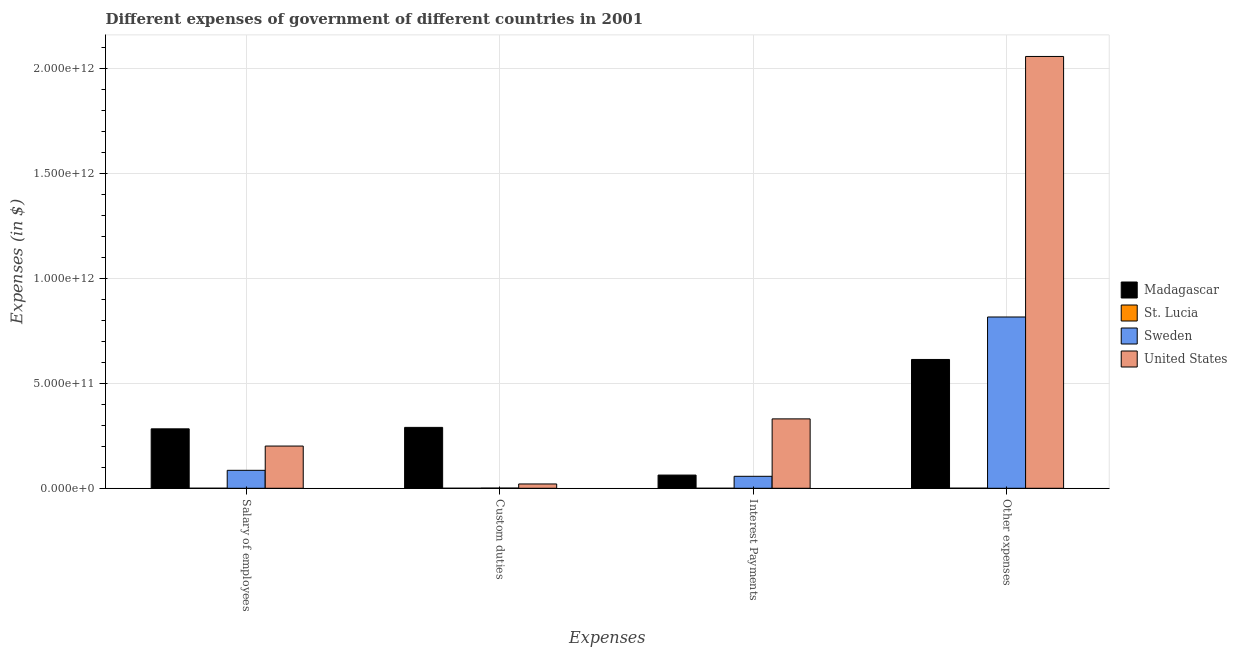How many groups of bars are there?
Give a very brief answer. 4. Are the number of bars per tick equal to the number of legend labels?
Provide a succinct answer. Yes. Are the number of bars on each tick of the X-axis equal?
Provide a short and direct response. Yes. What is the label of the 3rd group of bars from the left?
Your answer should be compact. Interest Payments. What is the amount spent on interest payments in St. Lucia?
Offer a very short reply. 4.08e+07. Across all countries, what is the maximum amount spent on other expenses?
Your answer should be very brief. 2.06e+12. Across all countries, what is the minimum amount spent on other expenses?
Provide a succinct answer. 4.01e+08. In which country was the amount spent on other expenses maximum?
Your answer should be compact. United States. In which country was the amount spent on salary of employees minimum?
Offer a terse response. St. Lucia. What is the total amount spent on salary of employees in the graph?
Offer a very short reply. 5.71e+11. What is the difference between the amount spent on other expenses in Madagascar and that in United States?
Provide a succinct answer. -1.45e+12. What is the difference between the amount spent on custom duties in Madagascar and the amount spent on other expenses in Sweden?
Offer a terse response. -5.27e+11. What is the average amount spent on custom duties per country?
Make the answer very short. 7.80e+1. What is the difference between the amount spent on custom duties and amount spent on other expenses in St. Lucia?
Provide a succinct answer. -3.18e+08. What is the ratio of the amount spent on custom duties in Madagascar to that in St. Lucia?
Make the answer very short. 3520.24. Is the amount spent on other expenses in Sweden less than that in Madagascar?
Keep it short and to the point. No. What is the difference between the highest and the second highest amount spent on custom duties?
Keep it short and to the point. 2.70e+11. What is the difference between the highest and the lowest amount spent on interest payments?
Keep it short and to the point. 3.31e+11. In how many countries, is the amount spent on other expenses greater than the average amount spent on other expenses taken over all countries?
Your answer should be very brief. 1. What does the 1st bar from the left in Other expenses represents?
Keep it short and to the point. Madagascar. What does the 2nd bar from the right in Salary of employees represents?
Your answer should be very brief. Sweden. How many bars are there?
Keep it short and to the point. 16. Are all the bars in the graph horizontal?
Provide a short and direct response. No. How many countries are there in the graph?
Your response must be concise. 4. What is the difference between two consecutive major ticks on the Y-axis?
Offer a terse response. 5.00e+11. Are the values on the major ticks of Y-axis written in scientific E-notation?
Make the answer very short. Yes. Does the graph contain grids?
Provide a succinct answer. Yes. How many legend labels are there?
Your answer should be compact. 4. How are the legend labels stacked?
Your response must be concise. Vertical. What is the title of the graph?
Your answer should be very brief. Different expenses of government of different countries in 2001. Does "Iran" appear as one of the legend labels in the graph?
Your answer should be very brief. No. What is the label or title of the X-axis?
Provide a short and direct response. Expenses. What is the label or title of the Y-axis?
Make the answer very short. Expenses (in $). What is the Expenses (in $) in Madagascar in Salary of employees?
Provide a succinct answer. 2.84e+11. What is the Expenses (in $) in St. Lucia in Salary of employees?
Offer a terse response. 2.14e+08. What is the Expenses (in $) in Sweden in Salary of employees?
Make the answer very short. 8.57e+1. What is the Expenses (in $) of United States in Salary of employees?
Keep it short and to the point. 2.01e+11. What is the Expenses (in $) of Madagascar in Custom duties?
Give a very brief answer. 2.90e+11. What is the Expenses (in $) in St. Lucia in Custom duties?
Offer a very short reply. 8.25e+07. What is the Expenses (in $) of Sweden in Custom duties?
Give a very brief answer. 9.37e+08. What is the Expenses (in $) of United States in Custom duties?
Keep it short and to the point. 2.06e+1. What is the Expenses (in $) in Madagascar in Interest Payments?
Your answer should be very brief. 6.30e+1. What is the Expenses (in $) in St. Lucia in Interest Payments?
Offer a very short reply. 4.08e+07. What is the Expenses (in $) of Sweden in Interest Payments?
Your answer should be very brief. 5.71e+1. What is the Expenses (in $) of United States in Interest Payments?
Offer a terse response. 3.31e+11. What is the Expenses (in $) of Madagascar in Other expenses?
Give a very brief answer. 6.14e+11. What is the Expenses (in $) of St. Lucia in Other expenses?
Offer a terse response. 4.01e+08. What is the Expenses (in $) of Sweden in Other expenses?
Your response must be concise. 8.17e+11. What is the Expenses (in $) in United States in Other expenses?
Offer a very short reply. 2.06e+12. Across all Expenses, what is the maximum Expenses (in $) in Madagascar?
Your answer should be compact. 6.14e+11. Across all Expenses, what is the maximum Expenses (in $) of St. Lucia?
Offer a terse response. 4.01e+08. Across all Expenses, what is the maximum Expenses (in $) of Sweden?
Offer a very short reply. 8.17e+11. Across all Expenses, what is the maximum Expenses (in $) of United States?
Your response must be concise. 2.06e+12. Across all Expenses, what is the minimum Expenses (in $) of Madagascar?
Offer a very short reply. 6.30e+1. Across all Expenses, what is the minimum Expenses (in $) in St. Lucia?
Your answer should be compact. 4.08e+07. Across all Expenses, what is the minimum Expenses (in $) in Sweden?
Your response must be concise. 9.37e+08. Across all Expenses, what is the minimum Expenses (in $) in United States?
Keep it short and to the point. 2.06e+1. What is the total Expenses (in $) in Madagascar in the graph?
Make the answer very short. 1.25e+12. What is the total Expenses (in $) in St. Lucia in the graph?
Keep it short and to the point. 7.38e+08. What is the total Expenses (in $) of Sweden in the graph?
Keep it short and to the point. 9.61e+11. What is the total Expenses (in $) in United States in the graph?
Make the answer very short. 2.61e+12. What is the difference between the Expenses (in $) in Madagascar in Salary of employees and that in Custom duties?
Ensure brevity in your answer.  -6.90e+09. What is the difference between the Expenses (in $) in St. Lucia in Salary of employees and that in Custom duties?
Your response must be concise. 1.31e+08. What is the difference between the Expenses (in $) in Sweden in Salary of employees and that in Custom duties?
Your answer should be compact. 8.48e+1. What is the difference between the Expenses (in $) of United States in Salary of employees and that in Custom duties?
Your answer should be compact. 1.81e+11. What is the difference between the Expenses (in $) of Madagascar in Salary of employees and that in Interest Payments?
Ensure brevity in your answer.  2.20e+11. What is the difference between the Expenses (in $) of St. Lucia in Salary of employees and that in Interest Payments?
Ensure brevity in your answer.  1.73e+08. What is the difference between the Expenses (in $) of Sweden in Salary of employees and that in Interest Payments?
Offer a terse response. 2.85e+1. What is the difference between the Expenses (in $) in United States in Salary of employees and that in Interest Payments?
Provide a succinct answer. -1.30e+11. What is the difference between the Expenses (in $) in Madagascar in Salary of employees and that in Other expenses?
Give a very brief answer. -3.31e+11. What is the difference between the Expenses (in $) of St. Lucia in Salary of employees and that in Other expenses?
Keep it short and to the point. -1.88e+08. What is the difference between the Expenses (in $) of Sweden in Salary of employees and that in Other expenses?
Make the answer very short. -7.31e+11. What is the difference between the Expenses (in $) of United States in Salary of employees and that in Other expenses?
Offer a very short reply. -1.86e+12. What is the difference between the Expenses (in $) in Madagascar in Custom duties and that in Interest Payments?
Offer a terse response. 2.27e+11. What is the difference between the Expenses (in $) in St. Lucia in Custom duties and that in Interest Payments?
Your response must be concise. 4.17e+07. What is the difference between the Expenses (in $) in Sweden in Custom duties and that in Interest Payments?
Your answer should be compact. -5.62e+1. What is the difference between the Expenses (in $) of United States in Custom duties and that in Interest Payments?
Offer a very short reply. -3.10e+11. What is the difference between the Expenses (in $) in Madagascar in Custom duties and that in Other expenses?
Make the answer very short. -3.24e+11. What is the difference between the Expenses (in $) of St. Lucia in Custom duties and that in Other expenses?
Provide a short and direct response. -3.18e+08. What is the difference between the Expenses (in $) in Sweden in Custom duties and that in Other expenses?
Your response must be concise. -8.16e+11. What is the difference between the Expenses (in $) in United States in Custom duties and that in Other expenses?
Give a very brief answer. -2.04e+12. What is the difference between the Expenses (in $) in Madagascar in Interest Payments and that in Other expenses?
Ensure brevity in your answer.  -5.51e+11. What is the difference between the Expenses (in $) in St. Lucia in Interest Payments and that in Other expenses?
Make the answer very short. -3.60e+08. What is the difference between the Expenses (in $) of Sweden in Interest Payments and that in Other expenses?
Your response must be concise. -7.60e+11. What is the difference between the Expenses (in $) in United States in Interest Payments and that in Other expenses?
Ensure brevity in your answer.  -1.73e+12. What is the difference between the Expenses (in $) in Madagascar in Salary of employees and the Expenses (in $) in St. Lucia in Custom duties?
Your answer should be very brief. 2.83e+11. What is the difference between the Expenses (in $) in Madagascar in Salary of employees and the Expenses (in $) in Sweden in Custom duties?
Offer a very short reply. 2.83e+11. What is the difference between the Expenses (in $) in Madagascar in Salary of employees and the Expenses (in $) in United States in Custom duties?
Make the answer very short. 2.63e+11. What is the difference between the Expenses (in $) in St. Lucia in Salary of employees and the Expenses (in $) in Sweden in Custom duties?
Keep it short and to the point. -7.24e+08. What is the difference between the Expenses (in $) of St. Lucia in Salary of employees and the Expenses (in $) of United States in Custom duties?
Give a very brief answer. -2.04e+1. What is the difference between the Expenses (in $) of Sweden in Salary of employees and the Expenses (in $) of United States in Custom duties?
Ensure brevity in your answer.  6.51e+1. What is the difference between the Expenses (in $) of Madagascar in Salary of employees and the Expenses (in $) of St. Lucia in Interest Payments?
Your answer should be compact. 2.83e+11. What is the difference between the Expenses (in $) in Madagascar in Salary of employees and the Expenses (in $) in Sweden in Interest Payments?
Keep it short and to the point. 2.26e+11. What is the difference between the Expenses (in $) in Madagascar in Salary of employees and the Expenses (in $) in United States in Interest Payments?
Provide a succinct answer. -4.75e+1. What is the difference between the Expenses (in $) in St. Lucia in Salary of employees and the Expenses (in $) in Sweden in Interest Payments?
Make the answer very short. -5.69e+1. What is the difference between the Expenses (in $) in St. Lucia in Salary of employees and the Expenses (in $) in United States in Interest Payments?
Your answer should be very brief. -3.31e+11. What is the difference between the Expenses (in $) in Sweden in Salary of employees and the Expenses (in $) in United States in Interest Payments?
Your response must be concise. -2.45e+11. What is the difference between the Expenses (in $) in Madagascar in Salary of employees and the Expenses (in $) in St. Lucia in Other expenses?
Ensure brevity in your answer.  2.83e+11. What is the difference between the Expenses (in $) of Madagascar in Salary of employees and the Expenses (in $) of Sweden in Other expenses?
Your answer should be very brief. -5.33e+11. What is the difference between the Expenses (in $) of Madagascar in Salary of employees and the Expenses (in $) of United States in Other expenses?
Offer a terse response. -1.78e+12. What is the difference between the Expenses (in $) of St. Lucia in Salary of employees and the Expenses (in $) of Sweden in Other expenses?
Provide a short and direct response. -8.17e+11. What is the difference between the Expenses (in $) of St. Lucia in Salary of employees and the Expenses (in $) of United States in Other expenses?
Offer a terse response. -2.06e+12. What is the difference between the Expenses (in $) of Sweden in Salary of employees and the Expenses (in $) of United States in Other expenses?
Make the answer very short. -1.97e+12. What is the difference between the Expenses (in $) of Madagascar in Custom duties and the Expenses (in $) of St. Lucia in Interest Payments?
Your response must be concise. 2.90e+11. What is the difference between the Expenses (in $) in Madagascar in Custom duties and the Expenses (in $) in Sweden in Interest Payments?
Your response must be concise. 2.33e+11. What is the difference between the Expenses (in $) of Madagascar in Custom duties and the Expenses (in $) of United States in Interest Payments?
Make the answer very short. -4.06e+1. What is the difference between the Expenses (in $) of St. Lucia in Custom duties and the Expenses (in $) of Sweden in Interest Payments?
Give a very brief answer. -5.71e+1. What is the difference between the Expenses (in $) of St. Lucia in Custom duties and the Expenses (in $) of United States in Interest Payments?
Your response must be concise. -3.31e+11. What is the difference between the Expenses (in $) in Sweden in Custom duties and the Expenses (in $) in United States in Interest Payments?
Your response must be concise. -3.30e+11. What is the difference between the Expenses (in $) in Madagascar in Custom duties and the Expenses (in $) in St. Lucia in Other expenses?
Provide a short and direct response. 2.90e+11. What is the difference between the Expenses (in $) of Madagascar in Custom duties and the Expenses (in $) of Sweden in Other expenses?
Give a very brief answer. -5.27e+11. What is the difference between the Expenses (in $) in Madagascar in Custom duties and the Expenses (in $) in United States in Other expenses?
Keep it short and to the point. -1.77e+12. What is the difference between the Expenses (in $) of St. Lucia in Custom duties and the Expenses (in $) of Sweden in Other expenses?
Provide a short and direct response. -8.17e+11. What is the difference between the Expenses (in $) in St. Lucia in Custom duties and the Expenses (in $) in United States in Other expenses?
Your answer should be compact. -2.06e+12. What is the difference between the Expenses (in $) in Sweden in Custom duties and the Expenses (in $) in United States in Other expenses?
Provide a short and direct response. -2.06e+12. What is the difference between the Expenses (in $) in Madagascar in Interest Payments and the Expenses (in $) in St. Lucia in Other expenses?
Give a very brief answer. 6.26e+1. What is the difference between the Expenses (in $) in Madagascar in Interest Payments and the Expenses (in $) in Sweden in Other expenses?
Offer a terse response. -7.54e+11. What is the difference between the Expenses (in $) in Madagascar in Interest Payments and the Expenses (in $) in United States in Other expenses?
Offer a terse response. -2.00e+12. What is the difference between the Expenses (in $) of St. Lucia in Interest Payments and the Expenses (in $) of Sweden in Other expenses?
Offer a very short reply. -8.17e+11. What is the difference between the Expenses (in $) in St. Lucia in Interest Payments and the Expenses (in $) in United States in Other expenses?
Keep it short and to the point. -2.06e+12. What is the difference between the Expenses (in $) of Sweden in Interest Payments and the Expenses (in $) of United States in Other expenses?
Ensure brevity in your answer.  -2.00e+12. What is the average Expenses (in $) in Madagascar per Expenses?
Make the answer very short. 3.13e+11. What is the average Expenses (in $) in St. Lucia per Expenses?
Your answer should be compact. 1.84e+08. What is the average Expenses (in $) of Sweden per Expenses?
Your answer should be very brief. 2.40e+11. What is the average Expenses (in $) in United States per Expenses?
Give a very brief answer. 6.53e+11. What is the difference between the Expenses (in $) of Madagascar and Expenses (in $) of St. Lucia in Salary of employees?
Provide a succinct answer. 2.83e+11. What is the difference between the Expenses (in $) of Madagascar and Expenses (in $) of Sweden in Salary of employees?
Offer a very short reply. 1.98e+11. What is the difference between the Expenses (in $) in Madagascar and Expenses (in $) in United States in Salary of employees?
Your answer should be very brief. 8.21e+1. What is the difference between the Expenses (in $) in St. Lucia and Expenses (in $) in Sweden in Salary of employees?
Provide a short and direct response. -8.55e+1. What is the difference between the Expenses (in $) of St. Lucia and Expenses (in $) of United States in Salary of employees?
Give a very brief answer. -2.01e+11. What is the difference between the Expenses (in $) of Sweden and Expenses (in $) of United States in Salary of employees?
Give a very brief answer. -1.16e+11. What is the difference between the Expenses (in $) in Madagascar and Expenses (in $) in St. Lucia in Custom duties?
Your answer should be compact. 2.90e+11. What is the difference between the Expenses (in $) in Madagascar and Expenses (in $) in Sweden in Custom duties?
Keep it short and to the point. 2.89e+11. What is the difference between the Expenses (in $) of Madagascar and Expenses (in $) of United States in Custom duties?
Your response must be concise. 2.70e+11. What is the difference between the Expenses (in $) in St. Lucia and Expenses (in $) in Sweden in Custom duties?
Offer a very short reply. -8.54e+08. What is the difference between the Expenses (in $) of St. Lucia and Expenses (in $) of United States in Custom duties?
Make the answer very short. -2.05e+1. What is the difference between the Expenses (in $) in Sweden and Expenses (in $) in United States in Custom duties?
Your answer should be compact. -1.97e+1. What is the difference between the Expenses (in $) in Madagascar and Expenses (in $) in St. Lucia in Interest Payments?
Provide a succinct answer. 6.30e+1. What is the difference between the Expenses (in $) in Madagascar and Expenses (in $) in Sweden in Interest Payments?
Give a very brief answer. 5.88e+09. What is the difference between the Expenses (in $) in Madagascar and Expenses (in $) in United States in Interest Payments?
Give a very brief answer. -2.68e+11. What is the difference between the Expenses (in $) in St. Lucia and Expenses (in $) in Sweden in Interest Payments?
Offer a terse response. -5.71e+1. What is the difference between the Expenses (in $) of St. Lucia and Expenses (in $) of United States in Interest Payments?
Your response must be concise. -3.31e+11. What is the difference between the Expenses (in $) in Sweden and Expenses (in $) in United States in Interest Payments?
Your response must be concise. -2.74e+11. What is the difference between the Expenses (in $) of Madagascar and Expenses (in $) of St. Lucia in Other expenses?
Provide a short and direct response. 6.14e+11. What is the difference between the Expenses (in $) of Madagascar and Expenses (in $) of Sweden in Other expenses?
Offer a terse response. -2.03e+11. What is the difference between the Expenses (in $) in Madagascar and Expenses (in $) in United States in Other expenses?
Your answer should be compact. -1.45e+12. What is the difference between the Expenses (in $) in St. Lucia and Expenses (in $) in Sweden in Other expenses?
Provide a short and direct response. -8.17e+11. What is the difference between the Expenses (in $) of St. Lucia and Expenses (in $) of United States in Other expenses?
Offer a terse response. -2.06e+12. What is the difference between the Expenses (in $) in Sweden and Expenses (in $) in United States in Other expenses?
Make the answer very short. -1.24e+12. What is the ratio of the Expenses (in $) of Madagascar in Salary of employees to that in Custom duties?
Provide a short and direct response. 0.98. What is the ratio of the Expenses (in $) in St. Lucia in Salary of employees to that in Custom duties?
Your answer should be compact. 2.59. What is the ratio of the Expenses (in $) in Sweden in Salary of employees to that in Custom duties?
Your answer should be compact. 91.45. What is the ratio of the Expenses (in $) of United States in Salary of employees to that in Custom duties?
Your answer should be compact. 9.78. What is the ratio of the Expenses (in $) of Madagascar in Salary of employees to that in Interest Payments?
Your answer should be very brief. 4.5. What is the ratio of the Expenses (in $) of St. Lucia in Salary of employees to that in Interest Payments?
Offer a terse response. 5.23. What is the ratio of the Expenses (in $) in Sweden in Salary of employees to that in Interest Payments?
Your response must be concise. 1.5. What is the ratio of the Expenses (in $) of United States in Salary of employees to that in Interest Payments?
Make the answer very short. 0.61. What is the ratio of the Expenses (in $) in Madagascar in Salary of employees to that in Other expenses?
Offer a terse response. 0.46. What is the ratio of the Expenses (in $) of St. Lucia in Salary of employees to that in Other expenses?
Your response must be concise. 0.53. What is the ratio of the Expenses (in $) of Sweden in Salary of employees to that in Other expenses?
Keep it short and to the point. 0.1. What is the ratio of the Expenses (in $) in United States in Salary of employees to that in Other expenses?
Your response must be concise. 0.1. What is the ratio of the Expenses (in $) of Madagascar in Custom duties to that in Interest Payments?
Offer a terse response. 4.61. What is the ratio of the Expenses (in $) of St. Lucia in Custom duties to that in Interest Payments?
Ensure brevity in your answer.  2.02. What is the ratio of the Expenses (in $) of Sweden in Custom duties to that in Interest Payments?
Your response must be concise. 0.02. What is the ratio of the Expenses (in $) of United States in Custom duties to that in Interest Payments?
Give a very brief answer. 0.06. What is the ratio of the Expenses (in $) of Madagascar in Custom duties to that in Other expenses?
Your response must be concise. 0.47. What is the ratio of the Expenses (in $) in St. Lucia in Custom duties to that in Other expenses?
Make the answer very short. 0.21. What is the ratio of the Expenses (in $) in Sweden in Custom duties to that in Other expenses?
Your answer should be very brief. 0. What is the ratio of the Expenses (in $) in Madagascar in Interest Payments to that in Other expenses?
Your answer should be compact. 0.1. What is the ratio of the Expenses (in $) in St. Lucia in Interest Payments to that in Other expenses?
Give a very brief answer. 0.1. What is the ratio of the Expenses (in $) of Sweden in Interest Payments to that in Other expenses?
Give a very brief answer. 0.07. What is the ratio of the Expenses (in $) of United States in Interest Payments to that in Other expenses?
Offer a very short reply. 0.16. What is the difference between the highest and the second highest Expenses (in $) in Madagascar?
Provide a short and direct response. 3.24e+11. What is the difference between the highest and the second highest Expenses (in $) in St. Lucia?
Offer a very short reply. 1.88e+08. What is the difference between the highest and the second highest Expenses (in $) of Sweden?
Give a very brief answer. 7.31e+11. What is the difference between the highest and the second highest Expenses (in $) of United States?
Offer a terse response. 1.73e+12. What is the difference between the highest and the lowest Expenses (in $) of Madagascar?
Provide a short and direct response. 5.51e+11. What is the difference between the highest and the lowest Expenses (in $) of St. Lucia?
Your answer should be very brief. 3.60e+08. What is the difference between the highest and the lowest Expenses (in $) in Sweden?
Offer a terse response. 8.16e+11. What is the difference between the highest and the lowest Expenses (in $) of United States?
Provide a short and direct response. 2.04e+12. 